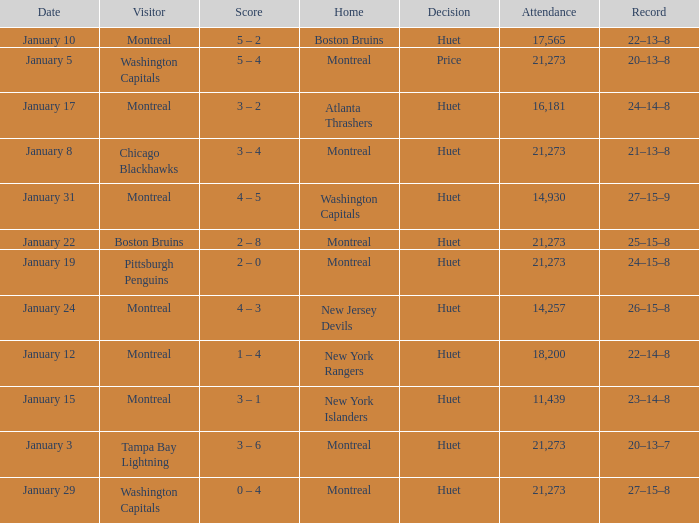What was the score of the game when the Boston Bruins were the visiting team? 2 – 8. 